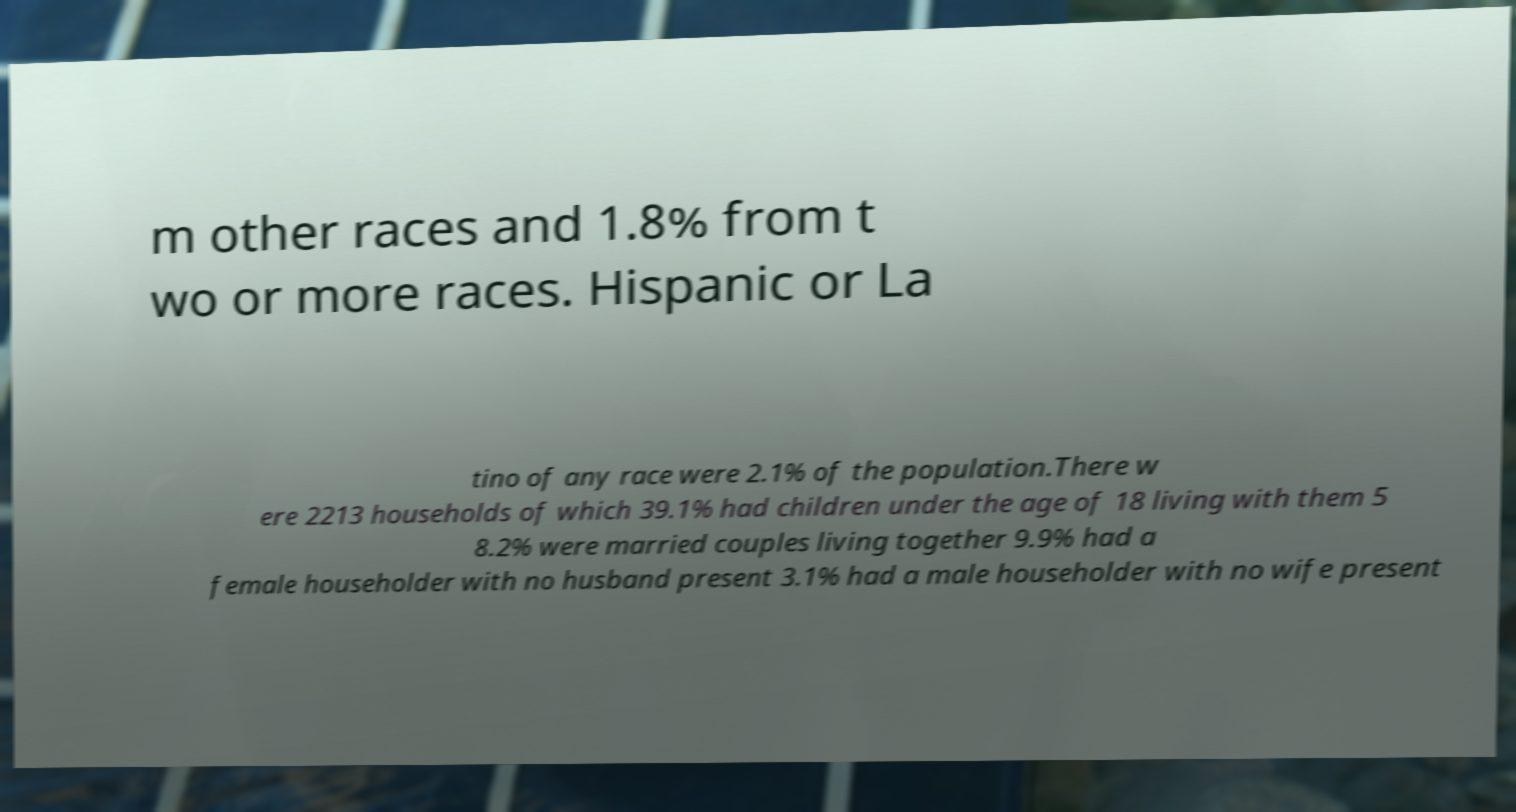Could you assist in decoding the text presented in this image and type it out clearly? m other races and 1.8% from t wo or more races. Hispanic or La tino of any race were 2.1% of the population.There w ere 2213 households of which 39.1% had children under the age of 18 living with them 5 8.2% were married couples living together 9.9% had a female householder with no husband present 3.1% had a male householder with no wife present 